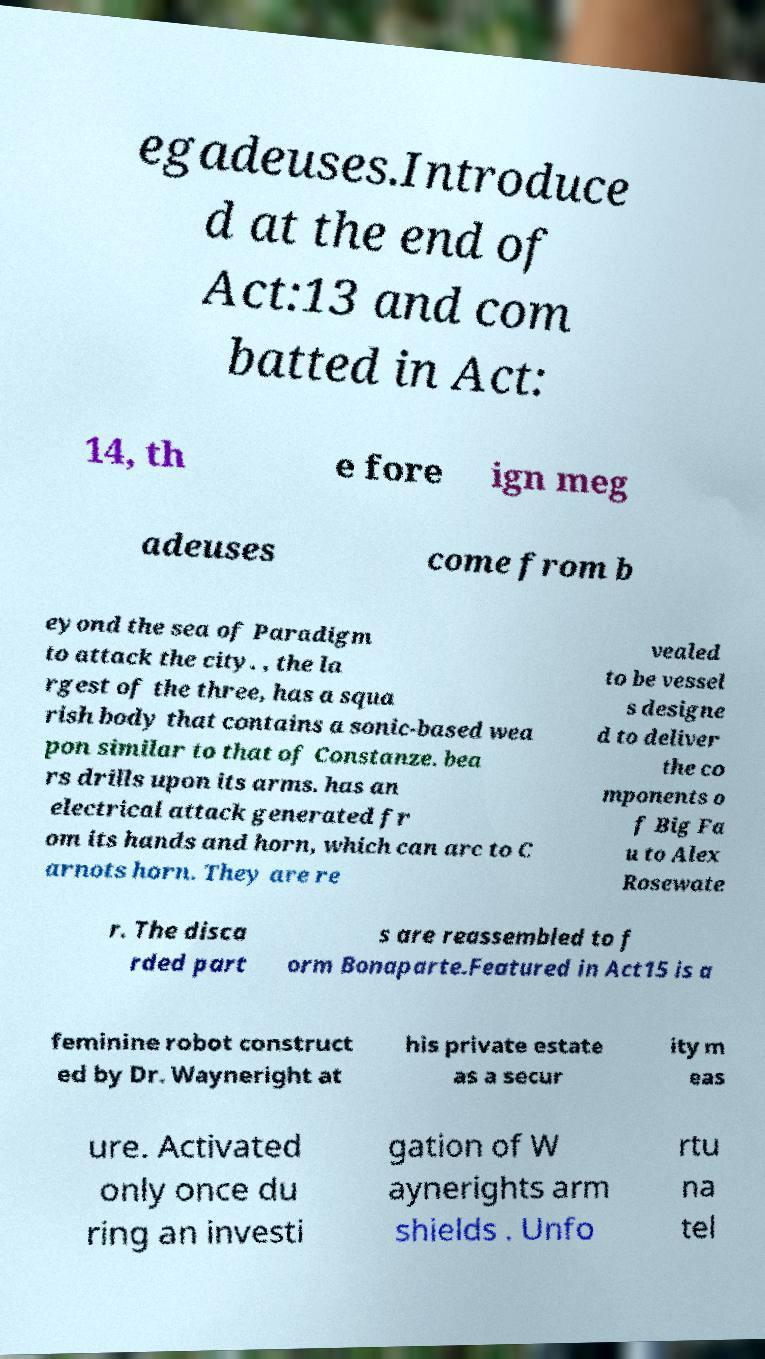There's text embedded in this image that I need extracted. Can you transcribe it verbatim? egadeuses.Introduce d at the end of Act:13 and com batted in Act: 14, th e fore ign meg adeuses come from b eyond the sea of Paradigm to attack the city. , the la rgest of the three, has a squa rish body that contains a sonic-based wea pon similar to that of Constanze. bea rs drills upon its arms. has an electrical attack generated fr om its hands and horn, which can arc to C arnots horn. They are re vealed to be vessel s designe d to deliver the co mponents o f Big Fa u to Alex Rosewate r. The disca rded part s are reassembled to f orm Bonaparte.Featured in Act15 is a feminine robot construct ed by Dr. Wayneright at his private estate as a secur ity m eas ure. Activated only once du ring an investi gation of W aynerights arm shields . Unfo rtu na tel 